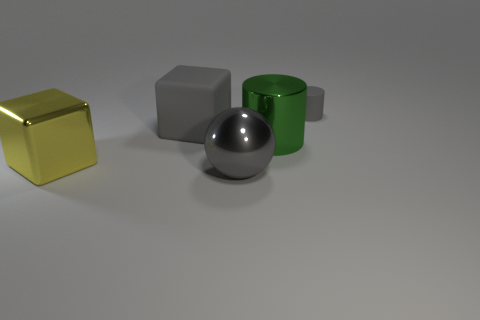What do you think the green cylinder is made of? Based on the image, the green cylinder appears to have a matte surface. This suggests it could be made of a material like colored glass with a frosted finish or a similarly treated plastic, which gives it a non-glossy appearance. Could it be used as a container? Given its cylindrical shape and open top, it's plausible that the green cylinder could serve as a container for holding items, although the specific use would depend on its actual size and the material's durability. 